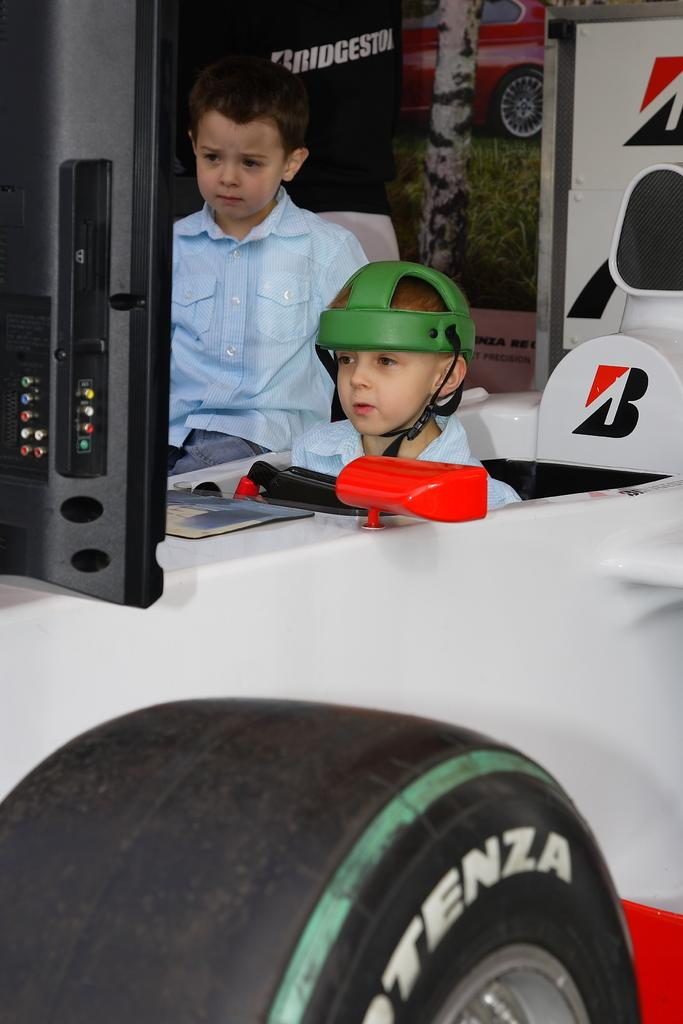How many kids are in the image? There are two kids in the image. What is the kid on the left side of the image wearing? One of the kids is wearing a green color helmet. Where is the kid with the helmet located? The kid with the helmet is sitting inside a vehicle. What can be seen in the background of the image? There is a poster in the background of the image. How is the poster positioned in the image? The poster is attached to a wall. Can you see any rabbits playing on the ground in the image? There are no rabbits or any ground visible in the image; it features two kids, one of whom is wearing a green helmet and sitting inside a vehicle, with a poster in the background. 